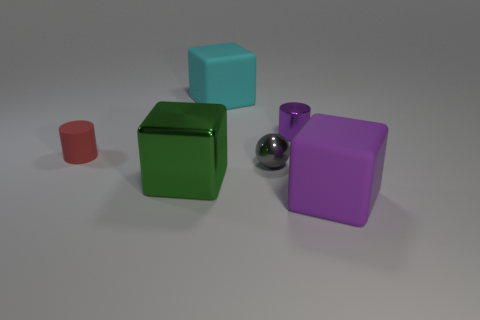Are there an equal number of big objects that are behind the tiny red rubber cylinder and large matte objects behind the gray object?
Provide a succinct answer. Yes. Is the material of the block behind the big green metallic block the same as the purple cube?
Provide a succinct answer. Yes. The object that is both right of the tiny gray metallic thing and behind the green metallic block is what color?
Give a very brief answer. Purple. What number of tiny red rubber cylinders are on the right side of the rubber object that is in front of the small red object?
Keep it short and to the point. 0. There is a large cyan object that is the same shape as the green object; what is it made of?
Provide a succinct answer. Rubber. What color is the tiny ball?
Offer a terse response. Gray. How many objects are either large purple rubber blocks or red matte cylinders?
Offer a very short reply. 2. There is a big thing behind the small object in front of the tiny red thing; what is its shape?
Make the answer very short. Cube. How many other things are the same material as the tiny red cylinder?
Your response must be concise. 2. Are the gray sphere and the small object that is to the right of the tiny gray metal sphere made of the same material?
Provide a succinct answer. Yes. 